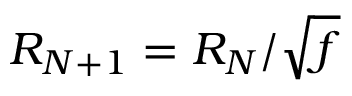Convert formula to latex. <formula><loc_0><loc_0><loc_500><loc_500>R _ { N + 1 } = R _ { N } / \sqrt { f }</formula> 